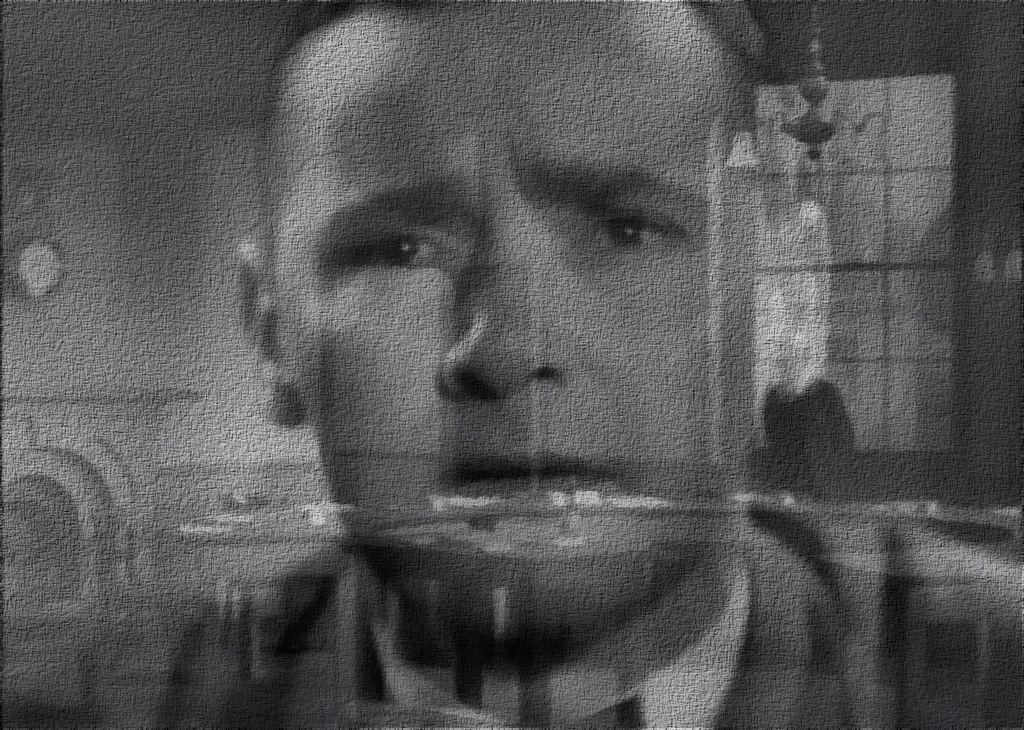What is the color scheme of the image? The image is black and white. What can be seen on the person's face in the image? The facts provided do not specify any details about the person's face. What type of structure is visible in the image? There is a wall visible in the image. What architectural feature is present in the image? There is a window in the image. How many squares can be seen on the person's face in the image? There are no squares visible on the person's face in the image, as it is a black and white image with no specific details about the face. What fact can be learned about the person's face from the image? The facts provided do not offer any specific details about the person's face, so no fact can be learned from the image. 